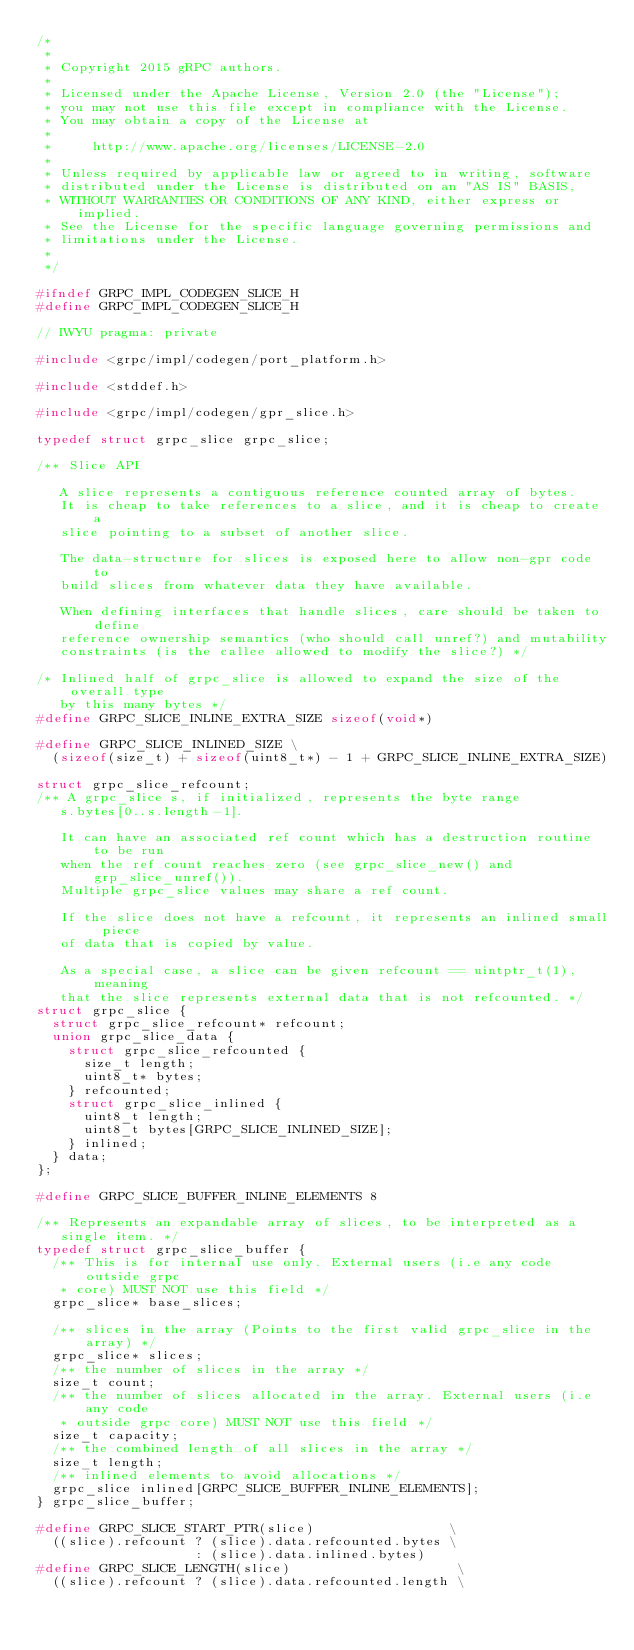Convert code to text. <code><loc_0><loc_0><loc_500><loc_500><_C_>/*
 *
 * Copyright 2015 gRPC authors.
 *
 * Licensed under the Apache License, Version 2.0 (the "License");
 * you may not use this file except in compliance with the License.
 * You may obtain a copy of the License at
 *
 *     http://www.apache.org/licenses/LICENSE-2.0
 *
 * Unless required by applicable law or agreed to in writing, software
 * distributed under the License is distributed on an "AS IS" BASIS,
 * WITHOUT WARRANTIES OR CONDITIONS OF ANY KIND, either express or implied.
 * See the License for the specific language governing permissions and
 * limitations under the License.
 *
 */

#ifndef GRPC_IMPL_CODEGEN_SLICE_H
#define GRPC_IMPL_CODEGEN_SLICE_H

// IWYU pragma: private

#include <grpc/impl/codegen/port_platform.h>

#include <stddef.h>

#include <grpc/impl/codegen/gpr_slice.h>

typedef struct grpc_slice grpc_slice;

/** Slice API

   A slice represents a contiguous reference counted array of bytes.
   It is cheap to take references to a slice, and it is cheap to create a
   slice pointing to a subset of another slice.

   The data-structure for slices is exposed here to allow non-gpr code to
   build slices from whatever data they have available.

   When defining interfaces that handle slices, care should be taken to define
   reference ownership semantics (who should call unref?) and mutability
   constraints (is the callee allowed to modify the slice?) */

/* Inlined half of grpc_slice is allowed to expand the size of the overall type
   by this many bytes */
#define GRPC_SLICE_INLINE_EXTRA_SIZE sizeof(void*)

#define GRPC_SLICE_INLINED_SIZE \
  (sizeof(size_t) + sizeof(uint8_t*) - 1 + GRPC_SLICE_INLINE_EXTRA_SIZE)

struct grpc_slice_refcount;
/** A grpc_slice s, if initialized, represents the byte range
   s.bytes[0..s.length-1].

   It can have an associated ref count which has a destruction routine to be run
   when the ref count reaches zero (see grpc_slice_new() and grp_slice_unref()).
   Multiple grpc_slice values may share a ref count.

   If the slice does not have a refcount, it represents an inlined small piece
   of data that is copied by value.

   As a special case, a slice can be given refcount == uintptr_t(1), meaning
   that the slice represents external data that is not refcounted. */
struct grpc_slice {
  struct grpc_slice_refcount* refcount;
  union grpc_slice_data {
    struct grpc_slice_refcounted {
      size_t length;
      uint8_t* bytes;
    } refcounted;
    struct grpc_slice_inlined {
      uint8_t length;
      uint8_t bytes[GRPC_SLICE_INLINED_SIZE];
    } inlined;
  } data;
};

#define GRPC_SLICE_BUFFER_INLINE_ELEMENTS 8

/** Represents an expandable array of slices, to be interpreted as a
   single item. */
typedef struct grpc_slice_buffer {
  /** This is for internal use only. External users (i.e any code outside grpc
   * core) MUST NOT use this field */
  grpc_slice* base_slices;

  /** slices in the array (Points to the first valid grpc_slice in the array) */
  grpc_slice* slices;
  /** the number of slices in the array */
  size_t count;
  /** the number of slices allocated in the array. External users (i.e any code
   * outside grpc core) MUST NOT use this field */
  size_t capacity;
  /** the combined length of all slices in the array */
  size_t length;
  /** inlined elements to avoid allocations */
  grpc_slice inlined[GRPC_SLICE_BUFFER_INLINE_ELEMENTS];
} grpc_slice_buffer;

#define GRPC_SLICE_START_PTR(slice)                 \
  ((slice).refcount ? (slice).data.refcounted.bytes \
                    : (slice).data.inlined.bytes)
#define GRPC_SLICE_LENGTH(slice)                     \
  ((slice).refcount ? (slice).data.refcounted.length \</code> 